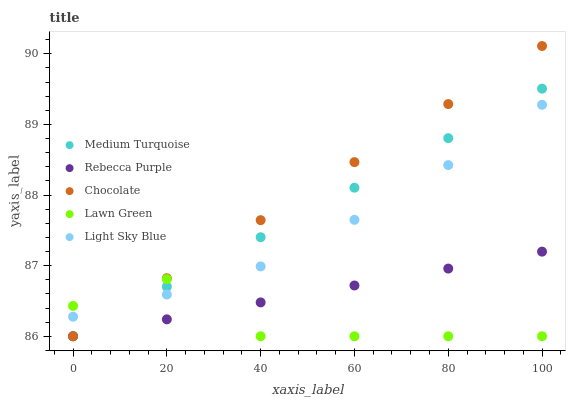Does Lawn Green have the minimum area under the curve?
Answer yes or no. Yes. Does Chocolate have the maximum area under the curve?
Answer yes or no. Yes. Does Light Sky Blue have the minimum area under the curve?
Answer yes or no. No. Does Light Sky Blue have the maximum area under the curve?
Answer yes or no. No. Is Medium Turquoise the smoothest?
Answer yes or no. Yes. Is Lawn Green the roughest?
Answer yes or no. Yes. Is Light Sky Blue the smoothest?
Answer yes or no. No. Is Light Sky Blue the roughest?
Answer yes or no. No. Does Lawn Green have the lowest value?
Answer yes or no. Yes. Does Light Sky Blue have the lowest value?
Answer yes or no. No. Does Chocolate have the highest value?
Answer yes or no. Yes. Does Light Sky Blue have the highest value?
Answer yes or no. No. Is Rebecca Purple less than Light Sky Blue?
Answer yes or no. Yes. Is Light Sky Blue greater than Rebecca Purple?
Answer yes or no. Yes. Does Chocolate intersect Medium Turquoise?
Answer yes or no. Yes. Is Chocolate less than Medium Turquoise?
Answer yes or no. No. Is Chocolate greater than Medium Turquoise?
Answer yes or no. No. Does Rebecca Purple intersect Light Sky Blue?
Answer yes or no. No. 